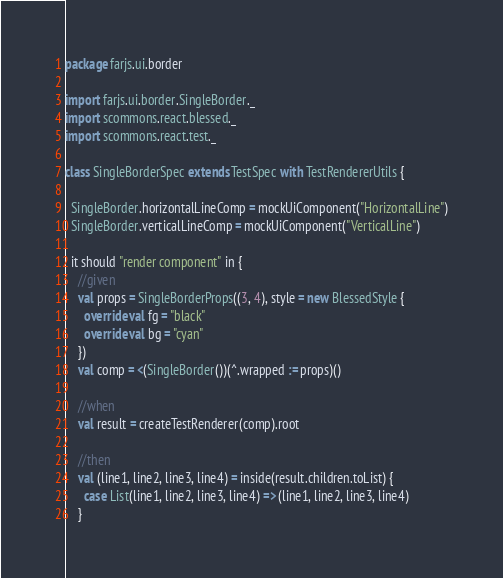<code> <loc_0><loc_0><loc_500><loc_500><_Scala_>package farjs.ui.border

import farjs.ui.border.SingleBorder._
import scommons.react.blessed._
import scommons.react.test._

class SingleBorderSpec extends TestSpec with TestRendererUtils {

  SingleBorder.horizontalLineComp = mockUiComponent("HorizontalLine")
  SingleBorder.verticalLineComp = mockUiComponent("VerticalLine")

  it should "render component" in {
    //given
    val props = SingleBorderProps((3, 4), style = new BlessedStyle {
      override val fg = "black"
      override val bg = "cyan"
    })
    val comp = <(SingleBorder())(^.wrapped := props)()

    //when
    val result = createTestRenderer(comp).root

    //then
    val (line1, line2, line3, line4) = inside(result.children.toList) {
      case List(line1, line2, line3, line4) => (line1, line2, line3, line4)
    }</code> 